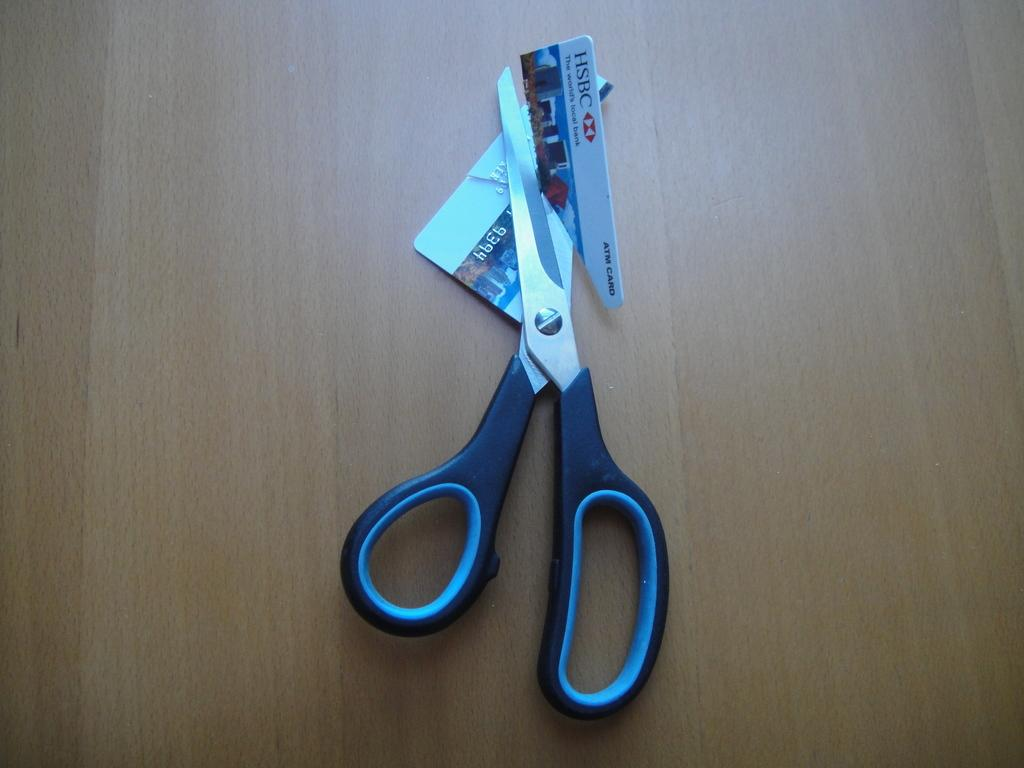What type of tool is present in the image? There are scissors in the image. What object is associated with the scissors in the image? There is a card in the image. What is the color of the surface on which the scissors and the card are placed? The scissors and the card are on a brown color surface. What type of tail can be seen on the scissors in the image? There is no tail present on the scissors in the image. What type of nail is being used to hold the card in the image? There is no nail visible in the image; the card is simply placed on the surface. 